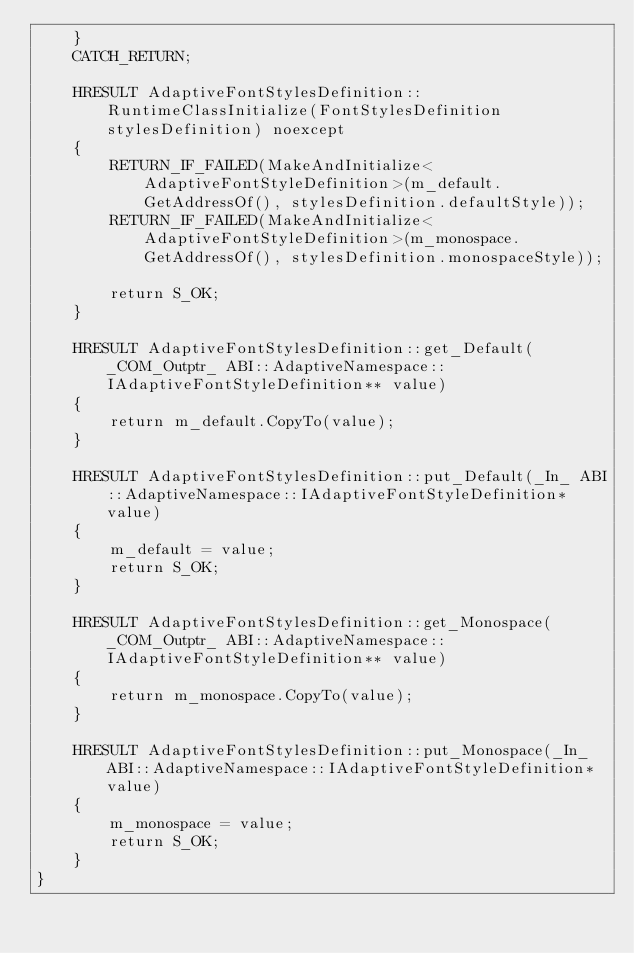Convert code to text. <code><loc_0><loc_0><loc_500><loc_500><_C++_>    }
    CATCH_RETURN;

    HRESULT AdaptiveFontStylesDefinition::RuntimeClassInitialize(FontStylesDefinition stylesDefinition) noexcept
    {
        RETURN_IF_FAILED(MakeAndInitialize<AdaptiveFontStyleDefinition>(m_default.GetAddressOf(), stylesDefinition.defaultStyle));
        RETURN_IF_FAILED(MakeAndInitialize<AdaptiveFontStyleDefinition>(m_monospace.GetAddressOf(), stylesDefinition.monospaceStyle));

        return S_OK;
    }

    HRESULT AdaptiveFontStylesDefinition::get_Default(_COM_Outptr_ ABI::AdaptiveNamespace::IAdaptiveFontStyleDefinition** value)
    {
        return m_default.CopyTo(value);
    }

    HRESULT AdaptiveFontStylesDefinition::put_Default(_In_ ABI::AdaptiveNamespace::IAdaptiveFontStyleDefinition* value)
    {
        m_default = value;
        return S_OK;
    }

    HRESULT AdaptiveFontStylesDefinition::get_Monospace(_COM_Outptr_ ABI::AdaptiveNamespace::IAdaptiveFontStyleDefinition** value)
    {
        return m_monospace.CopyTo(value);
    }

    HRESULT AdaptiveFontStylesDefinition::put_Monospace(_In_ ABI::AdaptiveNamespace::IAdaptiveFontStyleDefinition* value)
    {
        m_monospace = value;
        return S_OK;
    }
}
</code> 